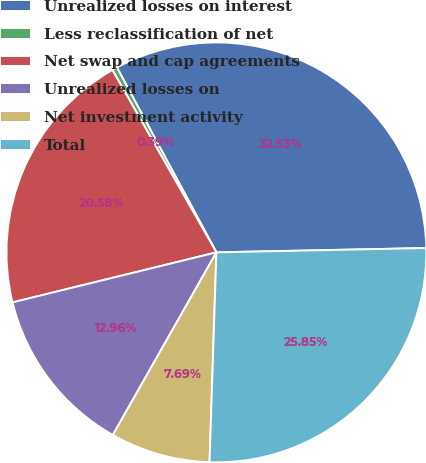Convert chart to OTSL. <chart><loc_0><loc_0><loc_500><loc_500><pie_chart><fcel>Unrealized losses on interest<fcel>Less reclassification of net<fcel>Net swap and cap agreements<fcel>Unrealized losses on<fcel>Net investment activity<fcel>Total<nl><fcel>32.53%<fcel>0.39%<fcel>20.58%<fcel>12.96%<fcel>7.69%<fcel>25.85%<nl></chart> 